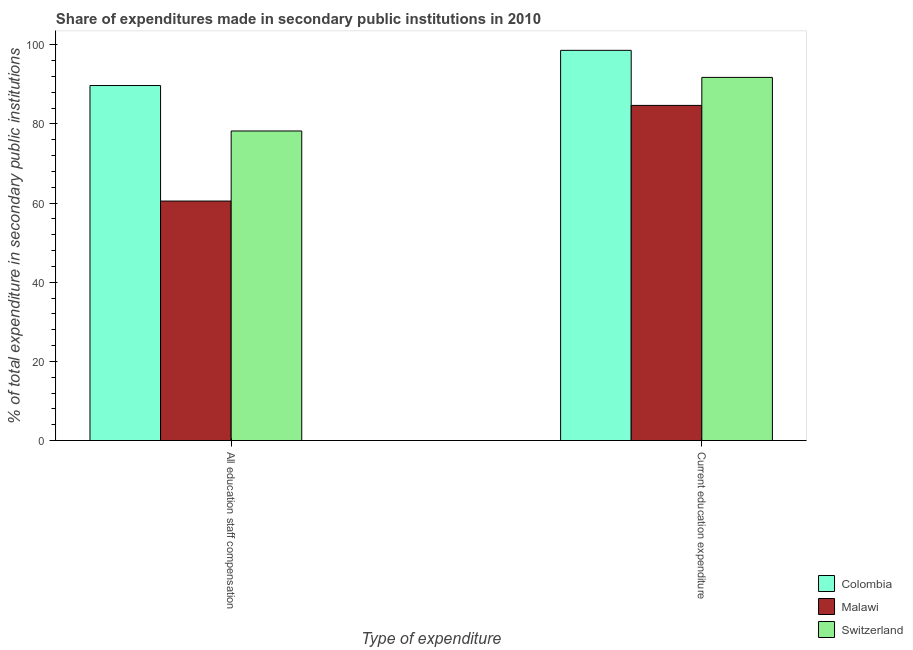How many different coloured bars are there?
Provide a short and direct response. 3. Are the number of bars per tick equal to the number of legend labels?
Your answer should be compact. Yes. How many bars are there on the 1st tick from the left?
Your response must be concise. 3. How many bars are there on the 1st tick from the right?
Your response must be concise. 3. What is the label of the 1st group of bars from the left?
Provide a succinct answer. All education staff compensation. What is the expenditure in staff compensation in Switzerland?
Your response must be concise. 78.22. Across all countries, what is the maximum expenditure in education?
Provide a succinct answer. 98.59. Across all countries, what is the minimum expenditure in staff compensation?
Your answer should be compact. 60.51. In which country was the expenditure in staff compensation minimum?
Provide a succinct answer. Malawi. What is the total expenditure in staff compensation in the graph?
Your response must be concise. 228.43. What is the difference between the expenditure in staff compensation in Malawi and that in Colombia?
Your answer should be very brief. -29.19. What is the difference between the expenditure in staff compensation in Malawi and the expenditure in education in Switzerland?
Offer a very short reply. -31.24. What is the average expenditure in education per country?
Keep it short and to the point. 91.68. What is the difference between the expenditure in education and expenditure in staff compensation in Switzerland?
Make the answer very short. 13.54. What is the ratio of the expenditure in staff compensation in Switzerland to that in Malawi?
Make the answer very short. 1.29. In how many countries, is the expenditure in staff compensation greater than the average expenditure in staff compensation taken over all countries?
Your answer should be very brief. 2. What does the 2nd bar from the left in All education staff compensation represents?
Offer a very short reply. Malawi. What does the 1st bar from the right in Current education expenditure represents?
Provide a succinct answer. Switzerland. How many bars are there?
Make the answer very short. 6. Are all the bars in the graph horizontal?
Give a very brief answer. No. How many countries are there in the graph?
Your response must be concise. 3. What is the difference between two consecutive major ticks on the Y-axis?
Ensure brevity in your answer.  20. Are the values on the major ticks of Y-axis written in scientific E-notation?
Keep it short and to the point. No. Does the graph contain any zero values?
Provide a succinct answer. No. What is the title of the graph?
Your response must be concise. Share of expenditures made in secondary public institutions in 2010. What is the label or title of the X-axis?
Make the answer very short. Type of expenditure. What is the label or title of the Y-axis?
Ensure brevity in your answer.  % of total expenditure in secondary public institutions. What is the % of total expenditure in secondary public institutions in Colombia in All education staff compensation?
Provide a succinct answer. 89.7. What is the % of total expenditure in secondary public institutions in Malawi in All education staff compensation?
Give a very brief answer. 60.51. What is the % of total expenditure in secondary public institutions of Switzerland in All education staff compensation?
Your answer should be very brief. 78.22. What is the % of total expenditure in secondary public institutions in Colombia in Current education expenditure?
Offer a very short reply. 98.59. What is the % of total expenditure in secondary public institutions in Malawi in Current education expenditure?
Your answer should be compact. 84.68. What is the % of total expenditure in secondary public institutions in Switzerland in Current education expenditure?
Provide a short and direct response. 91.76. Across all Type of expenditure, what is the maximum % of total expenditure in secondary public institutions in Colombia?
Offer a terse response. 98.59. Across all Type of expenditure, what is the maximum % of total expenditure in secondary public institutions of Malawi?
Provide a short and direct response. 84.68. Across all Type of expenditure, what is the maximum % of total expenditure in secondary public institutions in Switzerland?
Your response must be concise. 91.76. Across all Type of expenditure, what is the minimum % of total expenditure in secondary public institutions of Colombia?
Provide a short and direct response. 89.7. Across all Type of expenditure, what is the minimum % of total expenditure in secondary public institutions of Malawi?
Your answer should be very brief. 60.51. Across all Type of expenditure, what is the minimum % of total expenditure in secondary public institutions of Switzerland?
Your answer should be very brief. 78.22. What is the total % of total expenditure in secondary public institutions of Colombia in the graph?
Provide a short and direct response. 188.29. What is the total % of total expenditure in secondary public institutions of Malawi in the graph?
Provide a short and direct response. 145.19. What is the total % of total expenditure in secondary public institutions in Switzerland in the graph?
Provide a short and direct response. 169.97. What is the difference between the % of total expenditure in secondary public institutions in Colombia in All education staff compensation and that in Current education expenditure?
Offer a very short reply. -8.89. What is the difference between the % of total expenditure in secondary public institutions in Malawi in All education staff compensation and that in Current education expenditure?
Your response must be concise. -24.17. What is the difference between the % of total expenditure in secondary public institutions of Switzerland in All education staff compensation and that in Current education expenditure?
Keep it short and to the point. -13.54. What is the difference between the % of total expenditure in secondary public institutions in Colombia in All education staff compensation and the % of total expenditure in secondary public institutions in Malawi in Current education expenditure?
Provide a short and direct response. 5.02. What is the difference between the % of total expenditure in secondary public institutions of Colombia in All education staff compensation and the % of total expenditure in secondary public institutions of Switzerland in Current education expenditure?
Your response must be concise. -2.06. What is the difference between the % of total expenditure in secondary public institutions in Malawi in All education staff compensation and the % of total expenditure in secondary public institutions in Switzerland in Current education expenditure?
Your response must be concise. -31.24. What is the average % of total expenditure in secondary public institutions in Colombia per Type of expenditure?
Your answer should be very brief. 94.15. What is the average % of total expenditure in secondary public institutions of Malawi per Type of expenditure?
Offer a terse response. 72.6. What is the average % of total expenditure in secondary public institutions of Switzerland per Type of expenditure?
Offer a very short reply. 84.99. What is the difference between the % of total expenditure in secondary public institutions of Colombia and % of total expenditure in secondary public institutions of Malawi in All education staff compensation?
Give a very brief answer. 29.19. What is the difference between the % of total expenditure in secondary public institutions of Colombia and % of total expenditure in secondary public institutions of Switzerland in All education staff compensation?
Provide a succinct answer. 11.48. What is the difference between the % of total expenditure in secondary public institutions of Malawi and % of total expenditure in secondary public institutions of Switzerland in All education staff compensation?
Your response must be concise. -17.7. What is the difference between the % of total expenditure in secondary public institutions of Colombia and % of total expenditure in secondary public institutions of Malawi in Current education expenditure?
Keep it short and to the point. 13.91. What is the difference between the % of total expenditure in secondary public institutions in Colombia and % of total expenditure in secondary public institutions in Switzerland in Current education expenditure?
Offer a terse response. 6.84. What is the difference between the % of total expenditure in secondary public institutions of Malawi and % of total expenditure in secondary public institutions of Switzerland in Current education expenditure?
Your response must be concise. -7.08. What is the ratio of the % of total expenditure in secondary public institutions in Colombia in All education staff compensation to that in Current education expenditure?
Provide a short and direct response. 0.91. What is the ratio of the % of total expenditure in secondary public institutions in Malawi in All education staff compensation to that in Current education expenditure?
Your answer should be compact. 0.71. What is the ratio of the % of total expenditure in secondary public institutions of Switzerland in All education staff compensation to that in Current education expenditure?
Your answer should be compact. 0.85. What is the difference between the highest and the second highest % of total expenditure in secondary public institutions of Colombia?
Your response must be concise. 8.89. What is the difference between the highest and the second highest % of total expenditure in secondary public institutions of Malawi?
Provide a succinct answer. 24.17. What is the difference between the highest and the second highest % of total expenditure in secondary public institutions in Switzerland?
Provide a succinct answer. 13.54. What is the difference between the highest and the lowest % of total expenditure in secondary public institutions in Colombia?
Keep it short and to the point. 8.89. What is the difference between the highest and the lowest % of total expenditure in secondary public institutions in Malawi?
Your response must be concise. 24.17. What is the difference between the highest and the lowest % of total expenditure in secondary public institutions in Switzerland?
Your answer should be compact. 13.54. 